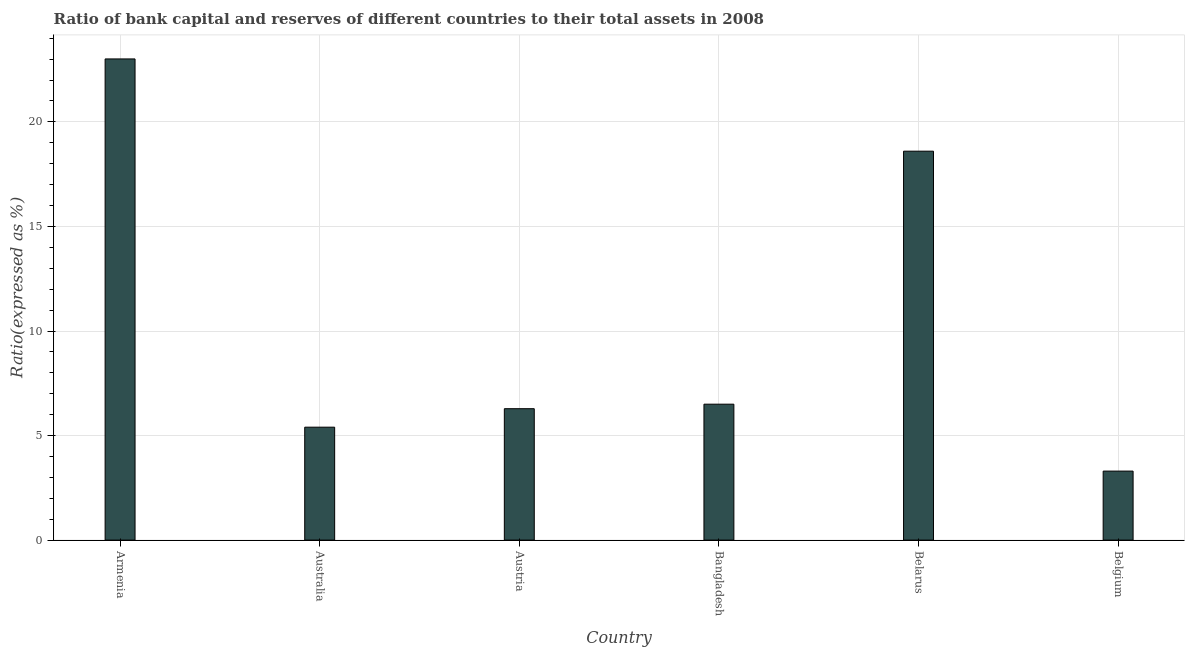Does the graph contain any zero values?
Your answer should be very brief. No. Does the graph contain grids?
Give a very brief answer. Yes. What is the title of the graph?
Your answer should be compact. Ratio of bank capital and reserves of different countries to their total assets in 2008. What is the label or title of the Y-axis?
Your answer should be very brief. Ratio(expressed as %). Across all countries, what is the maximum bank capital to assets ratio?
Ensure brevity in your answer.  23.01. In which country was the bank capital to assets ratio maximum?
Give a very brief answer. Armenia. What is the sum of the bank capital to assets ratio?
Provide a short and direct response. 63.1. What is the difference between the bank capital to assets ratio in Austria and Bangladesh?
Your response must be concise. -0.22. What is the average bank capital to assets ratio per country?
Your answer should be very brief. 10.52. What is the median bank capital to assets ratio?
Offer a terse response. 6.39. What is the ratio of the bank capital to assets ratio in Austria to that in Belarus?
Make the answer very short. 0.34. What is the difference between the highest and the second highest bank capital to assets ratio?
Your answer should be very brief. 4.41. Is the sum of the bank capital to assets ratio in Australia and Bangladesh greater than the maximum bank capital to assets ratio across all countries?
Your answer should be compact. No. What is the difference between the highest and the lowest bank capital to assets ratio?
Offer a very short reply. 19.71. Are all the bars in the graph horizontal?
Your answer should be very brief. No. Are the values on the major ticks of Y-axis written in scientific E-notation?
Provide a short and direct response. No. What is the Ratio(expressed as %) in Armenia?
Provide a succinct answer. 23.01. What is the Ratio(expressed as %) of Austria?
Provide a short and direct response. 6.28. What is the Ratio(expressed as %) of Bangladesh?
Offer a terse response. 6.5. What is the Ratio(expressed as %) in Belarus?
Provide a succinct answer. 18.6. What is the Ratio(expressed as %) in Belgium?
Your response must be concise. 3.3. What is the difference between the Ratio(expressed as %) in Armenia and Australia?
Give a very brief answer. 17.61. What is the difference between the Ratio(expressed as %) in Armenia and Austria?
Your answer should be compact. 16.73. What is the difference between the Ratio(expressed as %) in Armenia and Bangladesh?
Make the answer very short. 16.51. What is the difference between the Ratio(expressed as %) in Armenia and Belarus?
Your answer should be compact. 4.41. What is the difference between the Ratio(expressed as %) in Armenia and Belgium?
Provide a short and direct response. 19.71. What is the difference between the Ratio(expressed as %) in Australia and Austria?
Ensure brevity in your answer.  -0.88. What is the difference between the Ratio(expressed as %) in Australia and Bangladesh?
Your answer should be very brief. -1.1. What is the difference between the Ratio(expressed as %) in Australia and Belarus?
Your answer should be very brief. -13.2. What is the difference between the Ratio(expressed as %) in Australia and Belgium?
Make the answer very short. 2.1. What is the difference between the Ratio(expressed as %) in Austria and Bangladesh?
Give a very brief answer. -0.22. What is the difference between the Ratio(expressed as %) in Austria and Belarus?
Offer a terse response. -12.32. What is the difference between the Ratio(expressed as %) in Austria and Belgium?
Your answer should be very brief. 2.98. What is the difference between the Ratio(expressed as %) in Bangladesh and Belgium?
Provide a short and direct response. 3.2. What is the difference between the Ratio(expressed as %) in Belarus and Belgium?
Offer a very short reply. 15.3. What is the ratio of the Ratio(expressed as %) in Armenia to that in Australia?
Offer a terse response. 4.26. What is the ratio of the Ratio(expressed as %) in Armenia to that in Austria?
Provide a short and direct response. 3.66. What is the ratio of the Ratio(expressed as %) in Armenia to that in Bangladesh?
Make the answer very short. 3.54. What is the ratio of the Ratio(expressed as %) in Armenia to that in Belarus?
Your response must be concise. 1.24. What is the ratio of the Ratio(expressed as %) in Armenia to that in Belgium?
Keep it short and to the point. 6.97. What is the ratio of the Ratio(expressed as %) in Australia to that in Austria?
Make the answer very short. 0.86. What is the ratio of the Ratio(expressed as %) in Australia to that in Bangladesh?
Your response must be concise. 0.83. What is the ratio of the Ratio(expressed as %) in Australia to that in Belarus?
Keep it short and to the point. 0.29. What is the ratio of the Ratio(expressed as %) in Australia to that in Belgium?
Offer a very short reply. 1.64. What is the ratio of the Ratio(expressed as %) in Austria to that in Bangladesh?
Offer a terse response. 0.97. What is the ratio of the Ratio(expressed as %) in Austria to that in Belarus?
Provide a succinct answer. 0.34. What is the ratio of the Ratio(expressed as %) in Austria to that in Belgium?
Your answer should be very brief. 1.9. What is the ratio of the Ratio(expressed as %) in Bangladesh to that in Belarus?
Ensure brevity in your answer.  0.35. What is the ratio of the Ratio(expressed as %) in Bangladesh to that in Belgium?
Your response must be concise. 1.97. What is the ratio of the Ratio(expressed as %) in Belarus to that in Belgium?
Provide a short and direct response. 5.64. 